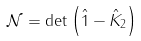Convert formula to latex. <formula><loc_0><loc_0><loc_500><loc_500>\mathcal { N } = \det \left ( \hat { 1 } - \hat { K } _ { 2 } \right )</formula> 